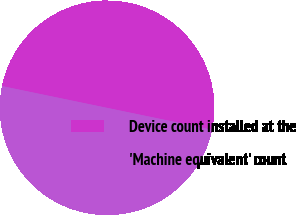<chart> <loc_0><loc_0><loc_500><loc_500><pie_chart><fcel>Device count installed at the<fcel>'Machine equivalent' count<nl><fcel>50.0%<fcel>50.0%<nl></chart> 